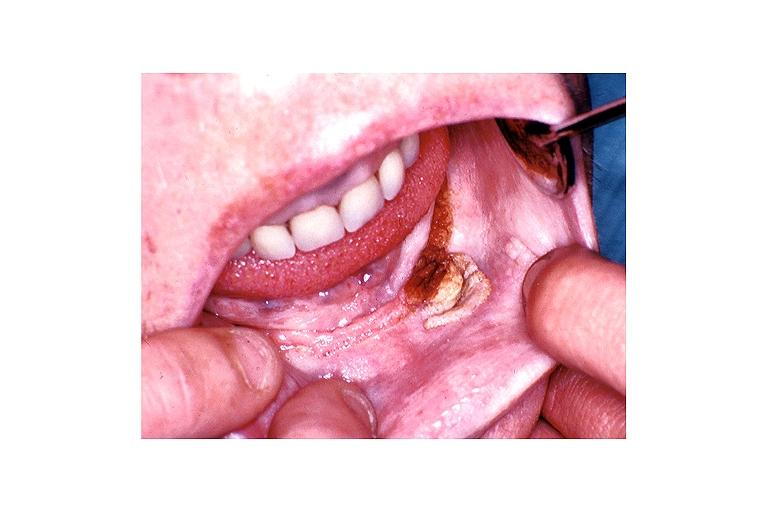s oral present?
Answer the question using a single word or phrase. Yes 